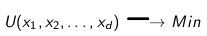<formula> <loc_0><loc_0><loc_500><loc_500>U ( x _ { 1 } , x _ { 2 } , \dots , x _ { d } ) \longrightarrow M i n</formula> 